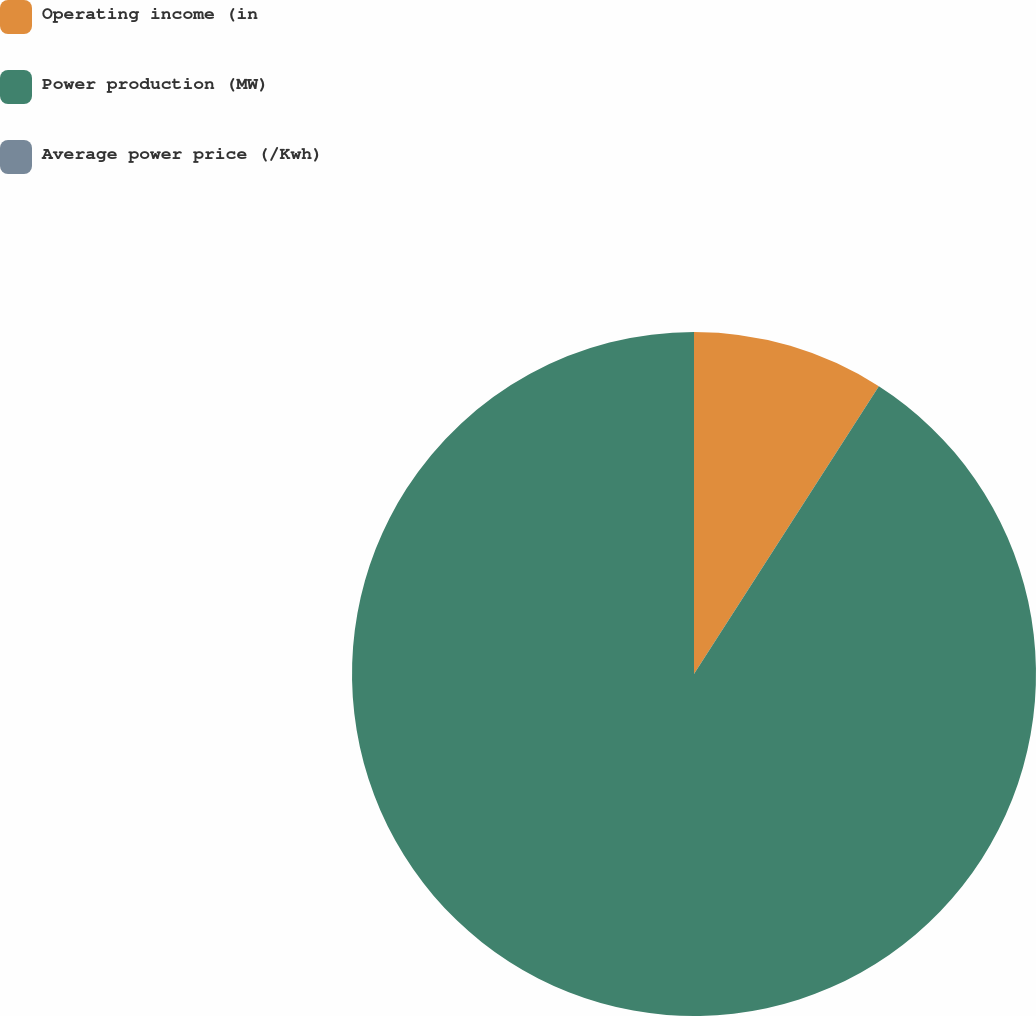Convert chart. <chart><loc_0><loc_0><loc_500><loc_500><pie_chart><fcel>Operating income (in<fcel>Power production (MW)<fcel>Average power price (/Kwh)<nl><fcel>9.09%<fcel>90.91%<fcel>0.0%<nl></chart> 